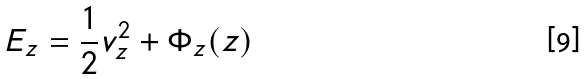Convert formula to latex. <formula><loc_0><loc_0><loc_500><loc_500>E _ { z } = \frac { 1 } { 2 } v _ { z } ^ { 2 } + \Phi _ { z } ( z )</formula> 